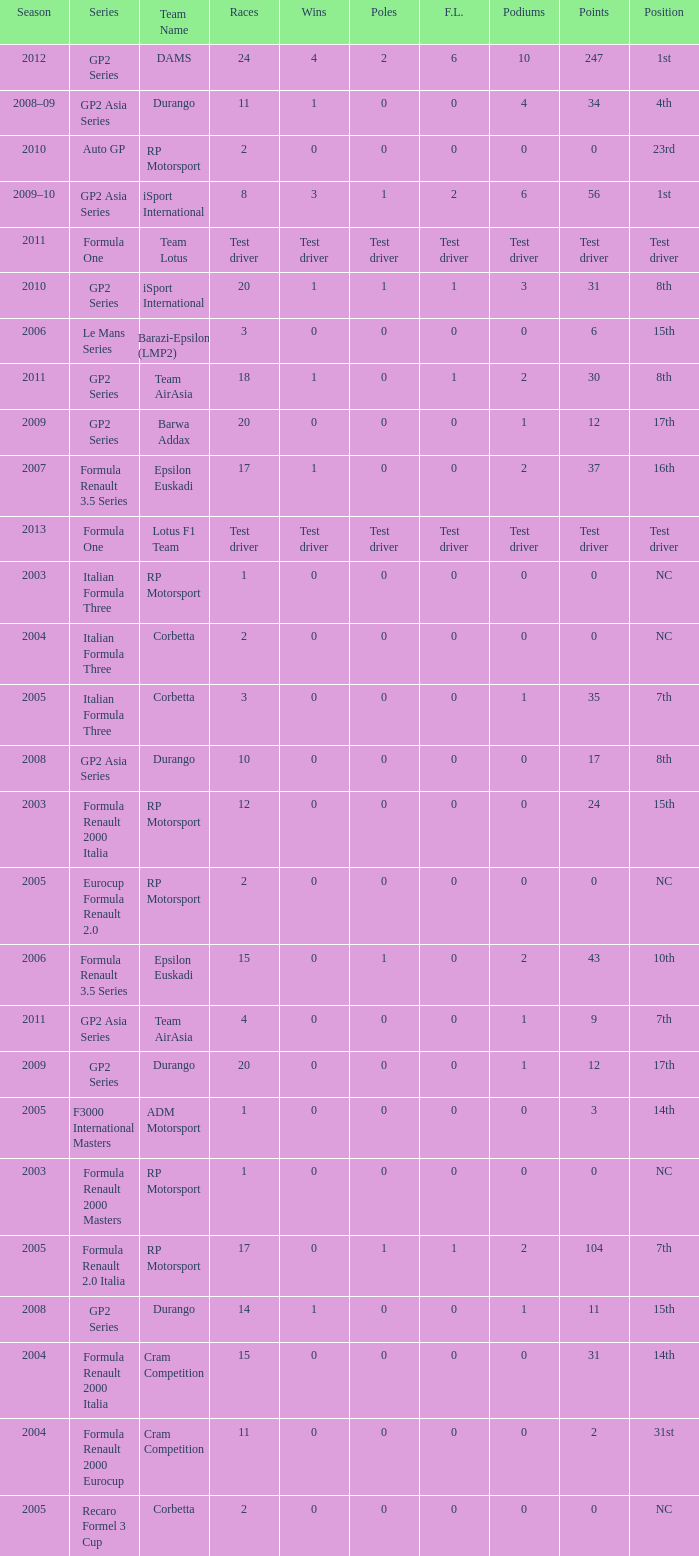What races have gp2 series, 0 F.L. and a 17th position? 20, 20. 